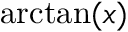Convert formula to latex. <formula><loc_0><loc_0><loc_500><loc_500>\arctan ( x )</formula> 